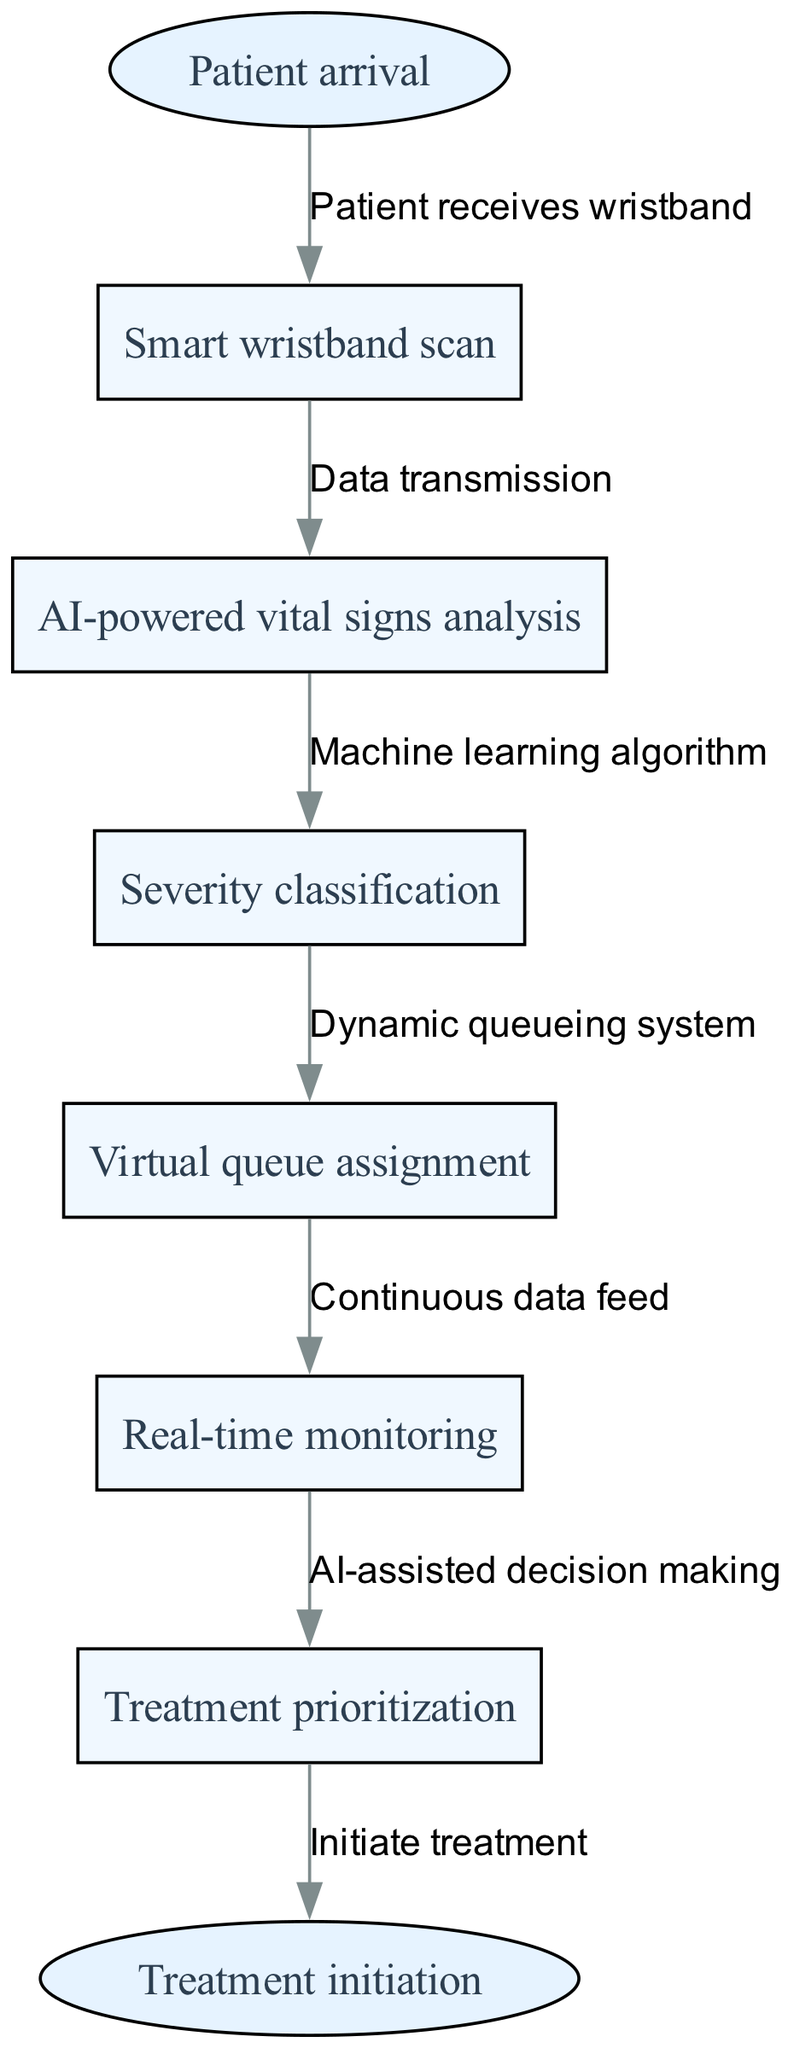What is the start point of the clinical pathway? The start point is explicitly labeled in the diagram as "Patient arrival." It serves as the initial entry into the clinical pathway, indicating when the patient first arrives at the emergency room.
Answer: Patient arrival How many nodes are in the diagram? The diagram contains six nodes, each representing a critical step in the triage process. These nodes include the smart wristband scan, AI-powered vital signs analysis, severity classification, virtual queue assignment, real-time monitoring, and treatment prioritization.
Answer: Six What type of data transmission occurs after scanning the smart wristband? The data transmission occurs between the first and second nodes, specifically labeled as "Data transmission." This indicates that data from the smart wristband is sent for analysis of vital signs.
Answer: Data transmission Which node uses a machine learning algorithm? The second node, which is labeled "AI-powered vital signs analysis," is where the machine learning algorithm is utilized to assess the received vital signs data further.
Answer: AI-powered vital signs analysis What happens after severity classification? Following the severity classification, the diagram shows that there is a "Dynamic queueing system," indicating that patients are assigned to a virtual queue based on the classification results.
Answer: Virtual queue assignment How does real-time monitoring relate to treatment prioritization? Real-time monitoring feeds continuous data into the treatment prioritization process, demonstrating that ongoing patient condition updates inform decisions regarding which patients need treatment first.
Answer: Continuous data feed Which node connects directly to the end point? The last node before reaching the end point is "Treatment prioritization." It connects directly to the end point labeled "Treatment initiation," indicating that treatment is initiated based on prioritization.
Answer: Treatment prioritization What system is used after severity classification? The system used after severity classification is a "Dynamic queueing system," which helps organize patients into a virtual queue for treatment based on their severity assessments.
Answer: Dynamic queueing system What is the final output of the clinical pathway? The final output, representing the end point of the clinical pathway, is indicated as "Treatment initiation," which signifies the start of the actual treatment process for the patient.
Answer: Treatment initiation 